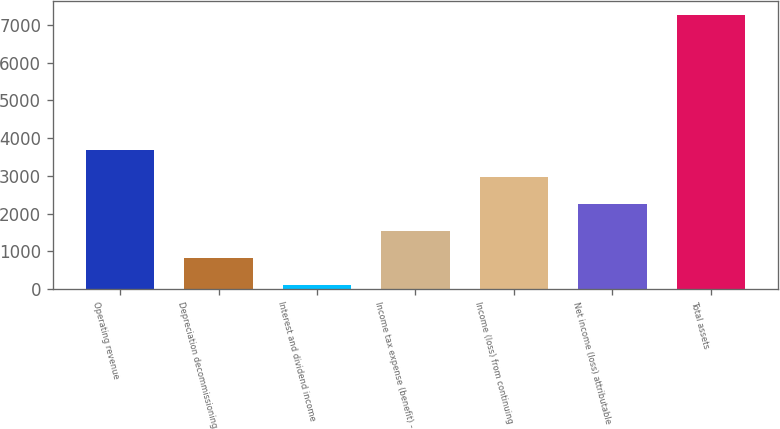Convert chart. <chart><loc_0><loc_0><loc_500><loc_500><bar_chart><fcel>Operating revenue<fcel>Depreciation decommissioning<fcel>Interest and dividend income<fcel>Income tax expense (benefit) -<fcel>Income (loss) from continuing<fcel>Net income (loss) attributable<fcel>Total assets<nl><fcel>3680.5<fcel>814.5<fcel>98<fcel>1531<fcel>2964<fcel>2247.5<fcel>7263<nl></chart> 